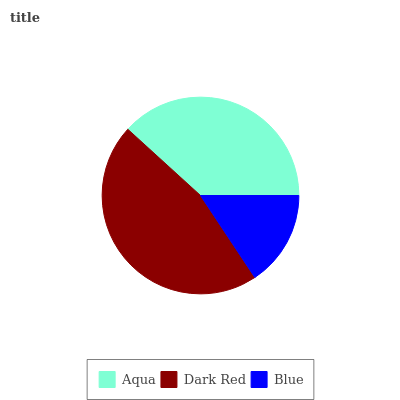Is Blue the minimum?
Answer yes or no. Yes. Is Dark Red the maximum?
Answer yes or no. Yes. Is Dark Red the minimum?
Answer yes or no. No. Is Blue the maximum?
Answer yes or no. No. Is Dark Red greater than Blue?
Answer yes or no. Yes. Is Blue less than Dark Red?
Answer yes or no. Yes. Is Blue greater than Dark Red?
Answer yes or no. No. Is Dark Red less than Blue?
Answer yes or no. No. Is Aqua the high median?
Answer yes or no. Yes. Is Aqua the low median?
Answer yes or no. Yes. Is Blue the high median?
Answer yes or no. No. Is Dark Red the low median?
Answer yes or no. No. 